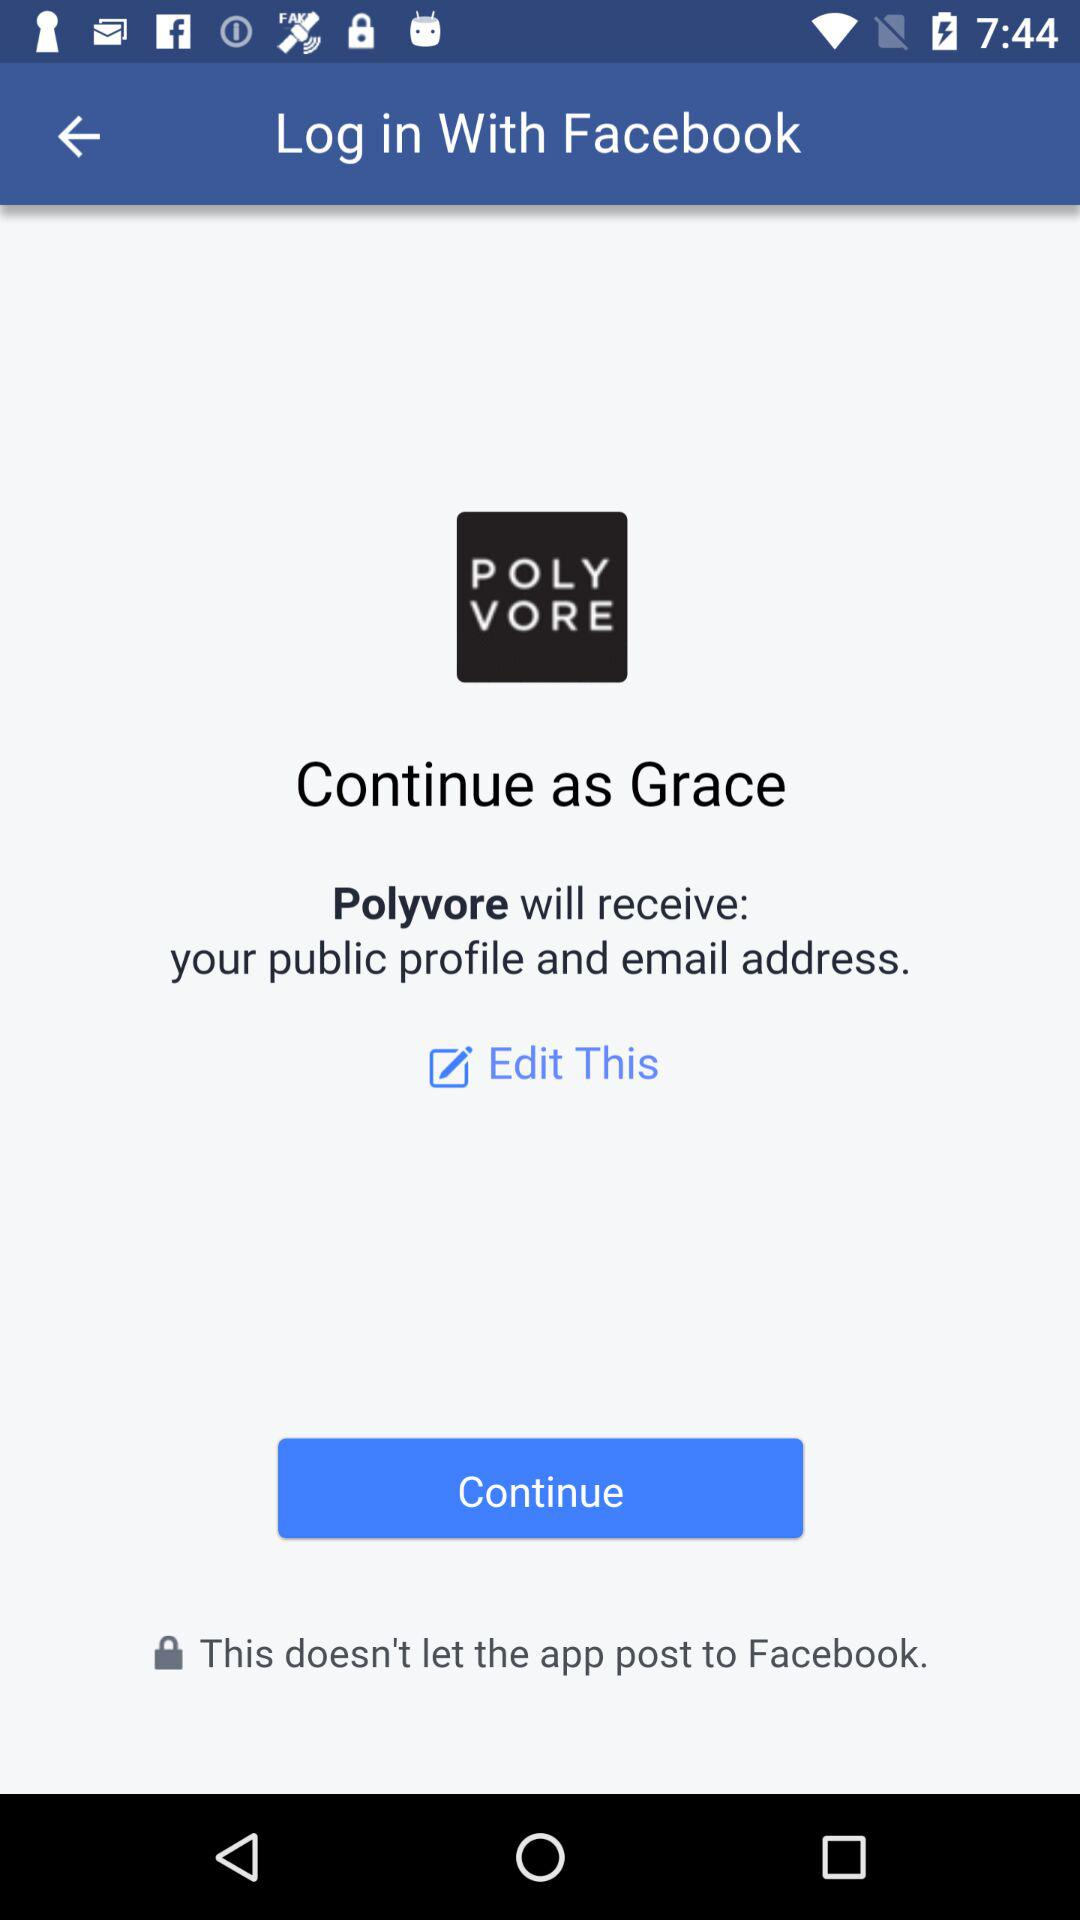What application is asking for permission? The application asking for permission is "Polyvore". 